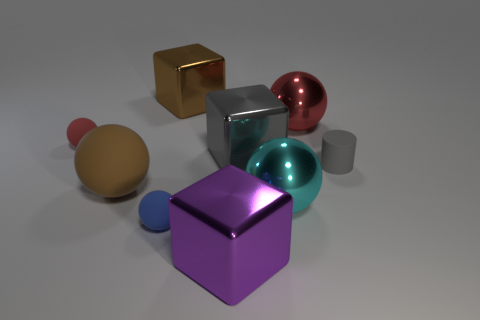There is a matte ball that is in front of the brown sphere; does it have the same size as the large red metal thing?
Offer a very short reply. No. Are there more small blue objects that are to the right of the large purple metallic thing than tiny gray rubber objects?
Keep it short and to the point. No. How many big gray metallic things are to the right of the large gray metal cube in front of the brown metallic thing?
Your answer should be very brief. 0. Are there fewer blocks behind the small blue rubber ball than cyan rubber cubes?
Provide a short and direct response. No. There is a red thing that is to the right of the large brown thing behind the small gray rubber cylinder; is there a red sphere in front of it?
Keep it short and to the point. Yes. Are the large brown block and the block in front of the cyan thing made of the same material?
Provide a short and direct response. Yes. There is a big shiny sphere that is behind the tiny thing that is right of the brown shiny cube; what is its color?
Give a very brief answer. Red. Are there any blocks of the same color as the big matte ball?
Ensure brevity in your answer.  Yes. There is a red ball that is right of the large cube that is behind the big block to the right of the large purple object; what size is it?
Your response must be concise. Large. Do the blue thing and the large brown matte object that is in front of the tiny gray thing have the same shape?
Your answer should be compact. Yes. 